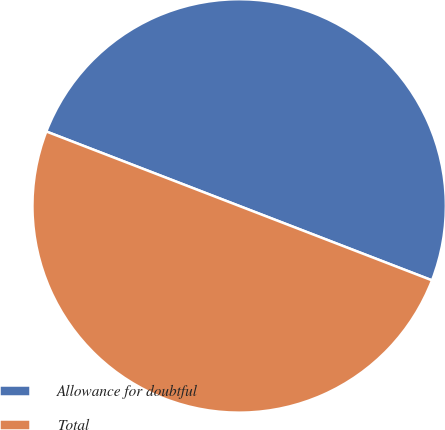Convert chart. <chart><loc_0><loc_0><loc_500><loc_500><pie_chart><fcel>Allowance for doubtful<fcel>Total<nl><fcel>50.0%<fcel>50.0%<nl></chart> 